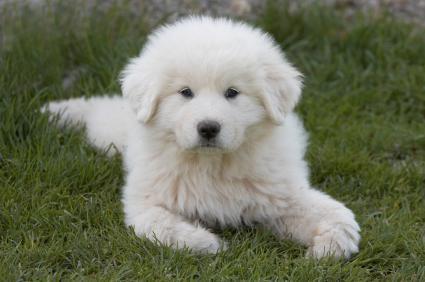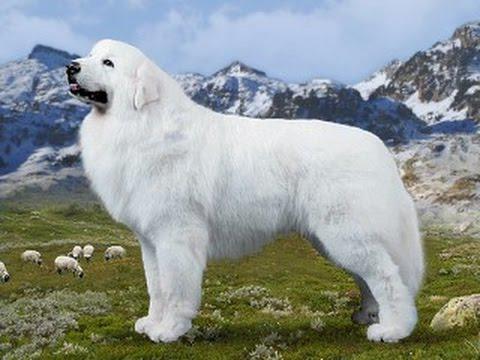The first image is the image on the left, the second image is the image on the right. Considering the images on both sides, is "The right image shows a white dog in profile with a nature backdrop." valid? Answer yes or no. Yes. The first image is the image on the left, the second image is the image on the right. Evaluate the accuracy of this statement regarding the images: "One image shows a puppy on the grass.". Is it true? Answer yes or no. Yes. 